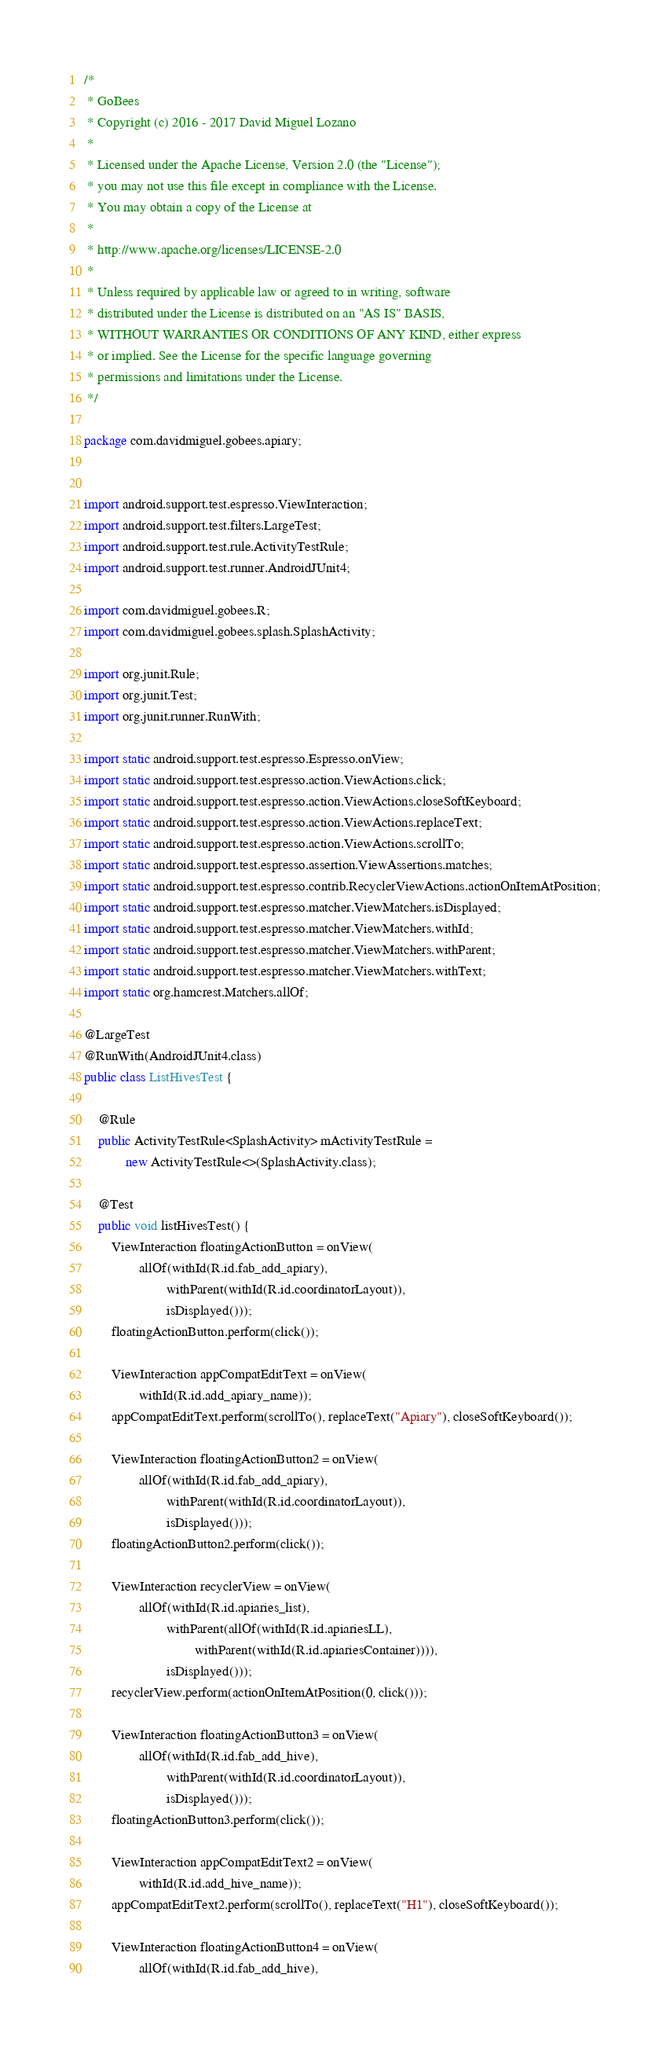Convert code to text. <code><loc_0><loc_0><loc_500><loc_500><_Java_>/*
 * GoBees
 * Copyright (c) 2016 - 2017 David Miguel Lozano
 *
 * Licensed under the Apache License, Version 2.0 (the "License");
 * you may not use this file except in compliance with the License.
 * You may obtain a copy of the License at
 *
 * http://www.apache.org/licenses/LICENSE-2.0
 *
 * Unless required by applicable law or agreed to in writing, software
 * distributed under the License is distributed on an "AS IS" BASIS,
 * WITHOUT WARRANTIES OR CONDITIONS OF ANY KIND, either express
 * or implied. See the License for the specific language governing
 * permissions and limitations under the License.
 */

package com.davidmiguel.gobees.apiary;


import android.support.test.espresso.ViewInteraction;
import android.support.test.filters.LargeTest;
import android.support.test.rule.ActivityTestRule;
import android.support.test.runner.AndroidJUnit4;

import com.davidmiguel.gobees.R;
import com.davidmiguel.gobees.splash.SplashActivity;

import org.junit.Rule;
import org.junit.Test;
import org.junit.runner.RunWith;

import static android.support.test.espresso.Espresso.onView;
import static android.support.test.espresso.action.ViewActions.click;
import static android.support.test.espresso.action.ViewActions.closeSoftKeyboard;
import static android.support.test.espresso.action.ViewActions.replaceText;
import static android.support.test.espresso.action.ViewActions.scrollTo;
import static android.support.test.espresso.assertion.ViewAssertions.matches;
import static android.support.test.espresso.contrib.RecyclerViewActions.actionOnItemAtPosition;
import static android.support.test.espresso.matcher.ViewMatchers.isDisplayed;
import static android.support.test.espresso.matcher.ViewMatchers.withId;
import static android.support.test.espresso.matcher.ViewMatchers.withParent;
import static android.support.test.espresso.matcher.ViewMatchers.withText;
import static org.hamcrest.Matchers.allOf;

@LargeTest
@RunWith(AndroidJUnit4.class)
public class ListHivesTest {

    @Rule
    public ActivityTestRule<SplashActivity> mActivityTestRule =
            new ActivityTestRule<>(SplashActivity.class);

    @Test
    public void listHivesTest() {
        ViewInteraction floatingActionButton = onView(
                allOf(withId(R.id.fab_add_apiary),
                        withParent(withId(R.id.coordinatorLayout)),
                        isDisplayed()));
        floatingActionButton.perform(click());

        ViewInteraction appCompatEditText = onView(
                withId(R.id.add_apiary_name));
        appCompatEditText.perform(scrollTo(), replaceText("Apiary"), closeSoftKeyboard());

        ViewInteraction floatingActionButton2 = onView(
                allOf(withId(R.id.fab_add_apiary),
                        withParent(withId(R.id.coordinatorLayout)),
                        isDisplayed()));
        floatingActionButton2.perform(click());

        ViewInteraction recyclerView = onView(
                allOf(withId(R.id.apiaries_list),
                        withParent(allOf(withId(R.id.apiariesLL),
                                withParent(withId(R.id.apiariesContainer)))),
                        isDisplayed()));
        recyclerView.perform(actionOnItemAtPosition(0, click()));

        ViewInteraction floatingActionButton3 = onView(
                allOf(withId(R.id.fab_add_hive),
                        withParent(withId(R.id.coordinatorLayout)),
                        isDisplayed()));
        floatingActionButton3.perform(click());

        ViewInteraction appCompatEditText2 = onView(
                withId(R.id.add_hive_name));
        appCompatEditText2.perform(scrollTo(), replaceText("H1"), closeSoftKeyboard());

        ViewInteraction floatingActionButton4 = onView(
                allOf(withId(R.id.fab_add_hive),</code> 